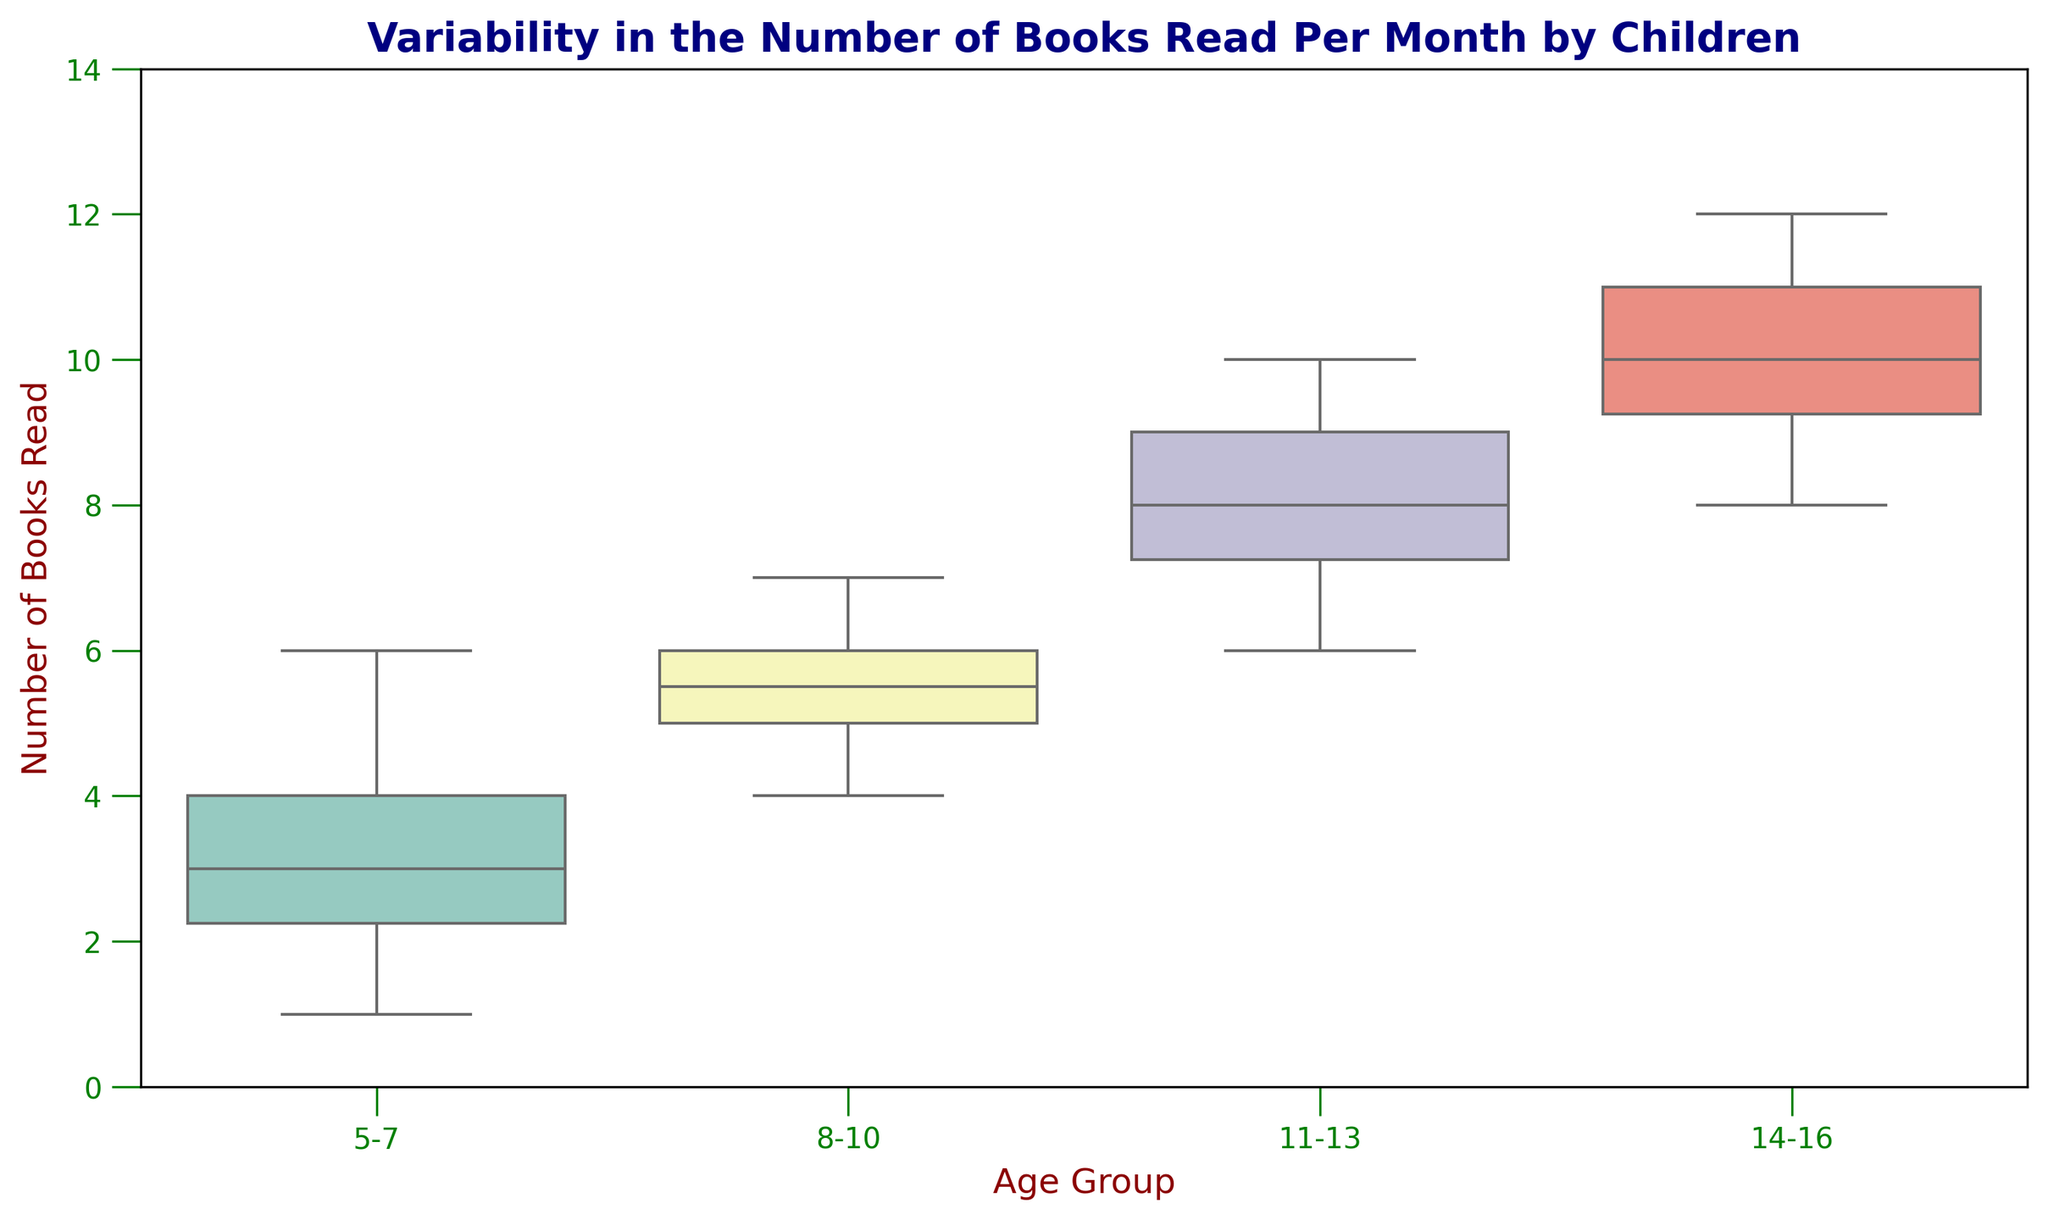What is the median number of books read by children in the age group 5-7? The median number of books read by children in the age group 5-7 can be found by looking at the line inside the box for this age group. The line inside the box represents the median value.
Answer: 3 Which age group reads the most books on average? The average number of books read can be inferred by looking at the position of the median line. The median line for the 14-16 age group appears to be the highest.
Answer: 14-16 Between the age groups 8-10 and 11-13, which has a higher maximum number of books read? The maximum number of books read is represented by the top whisker of the boxplot. For age group 11-13, the top whisker is higher than for the age group 8-10, indicating more books.
Answer: 11-13 Is there more variability in the number of books read by children in the 5-7 group or the 11-13 group? Variability is represented by the length of the box and whiskers. The box and whiskers for the 5-7 group are longer compared to the 11-13 group, indicating more variability.
Answer: 5-7 What is the interquartile range (IQR) for children aged 8-10? The IQR is the range between the first quartile (bottom of the box) and the third quartile (top of the box). Here, the first quartile is at 5, and the third quartile is around 6, making the IQR 6 - 5 = 1.
Answer: 1 Which age group has the smallest interquartile range (IQR)? The smallest IQR can be seen by looking at the boxes' length. The 8-10 age group has the shortest box, indicating the smallest IQR.
Answer: 8-10 In which age group do the children read at least 9 books per month most frequently? Looking at the boxplot for the 14-16 age group, both the median and a significant portion of the top quartile are above 9, indicating they frequently read at least 9 books per month.
Answer: 14-16 What is the range of books read per month by children aged 14-16? The range is the difference between the maximum and minimum values. For the 14-16 group, the maximum is around 12, and the minimum is around 8, so the range is 12 - 8 = 4 books.
Answer: 4 Which age group shows the least amount of variability in the number of books read? The least variability can be seen by the shortest box and whiskers. The 11-13 age group shows the least variability as their box and whiskers are relatively short.
Answer: 11-13 How do the median values for the 5-7 and 14-16 age groups compare? The median value for the 5-7 age group is 3, while for the 14-16 group, it is around 10. Therefore, the median for the 14-16 group is higher.
Answer: 14-16 